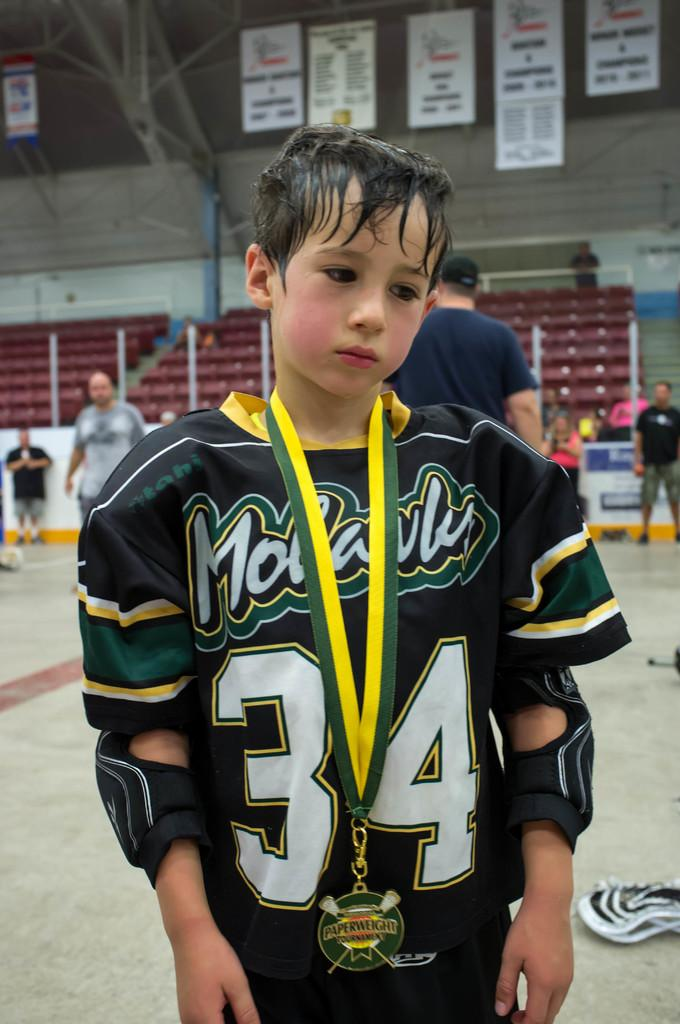<image>
Render a clear and concise summary of the photo. A boy with a medal around his neck and wearing number 34 